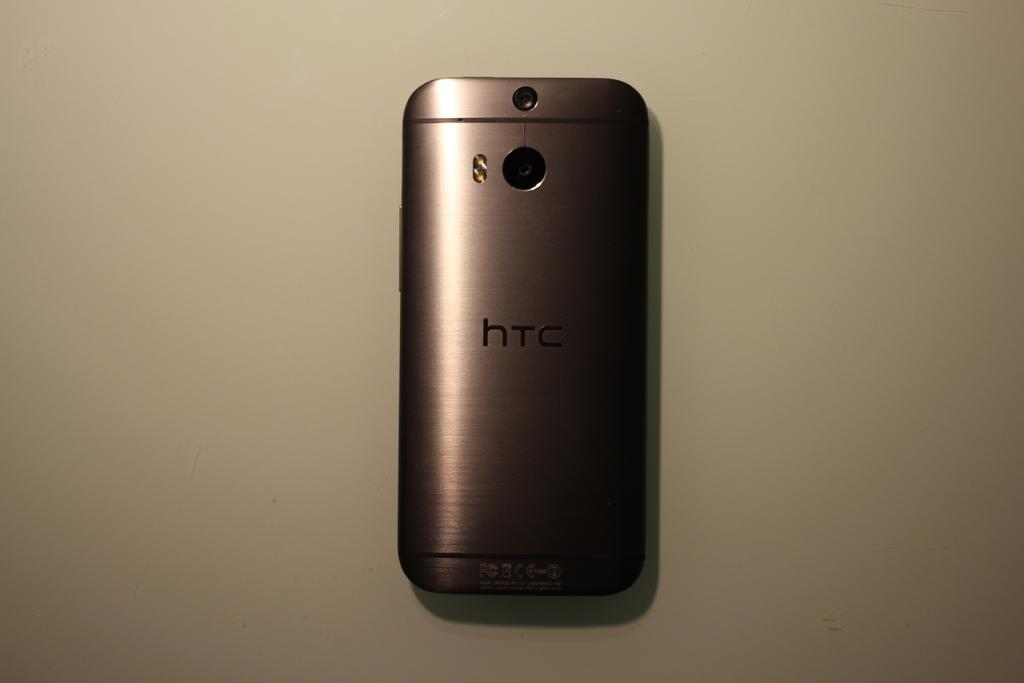<image>
Write a terse but informative summary of the picture. HTC is a manufacturer of cell phones with a small form. 